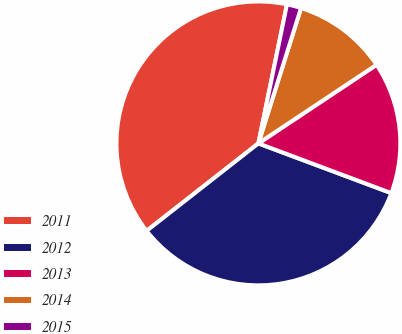Convert chart to OTSL. <chart><loc_0><loc_0><loc_500><loc_500><pie_chart><fcel>2011<fcel>2012<fcel>2013<fcel>2014<fcel>2015<nl><fcel>38.79%<fcel>33.73%<fcel>15.04%<fcel>10.8%<fcel>1.63%<nl></chart> 